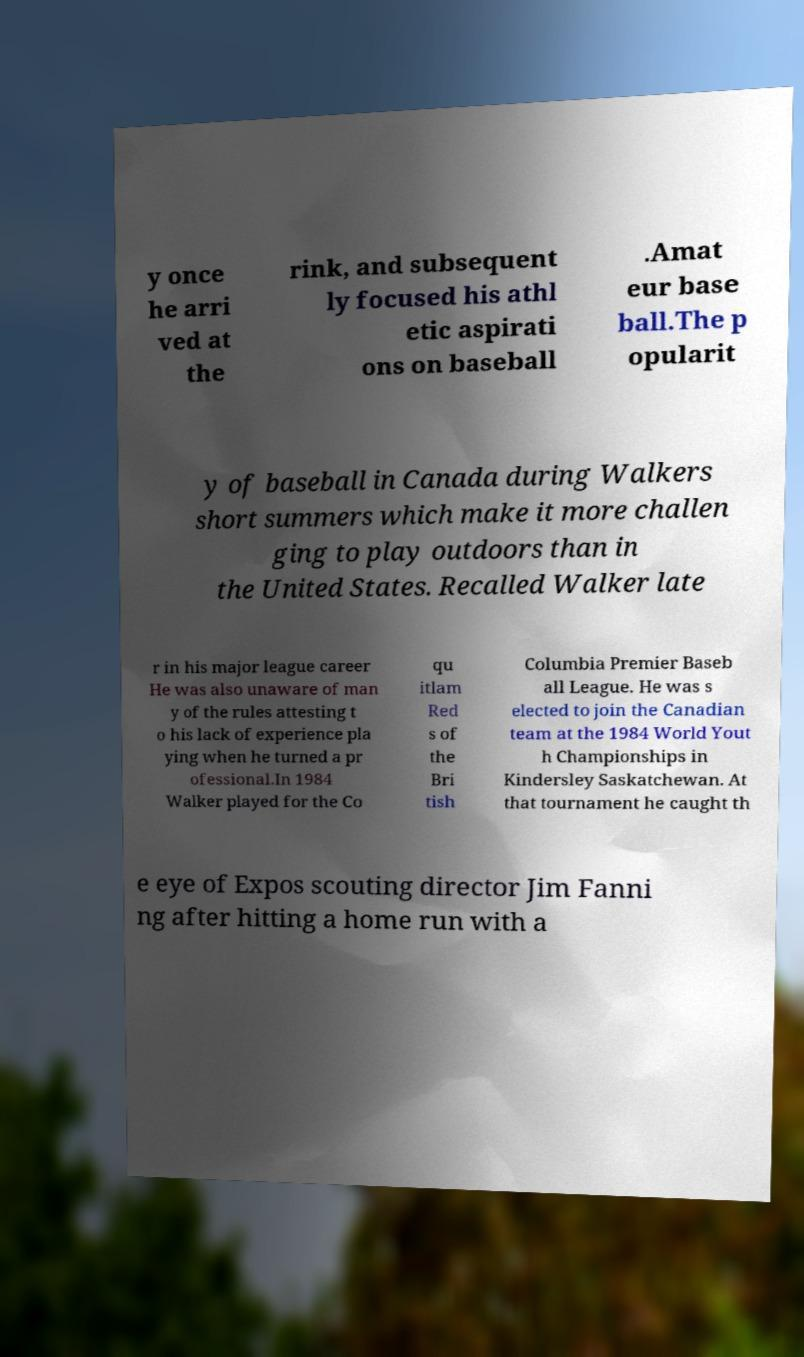Please read and relay the text visible in this image. What does it say? y once he arri ved at the rink, and subsequent ly focused his athl etic aspirati ons on baseball .Amat eur base ball.The p opularit y of baseball in Canada during Walkers short summers which make it more challen ging to play outdoors than in the United States. Recalled Walker late r in his major league career He was also unaware of man y of the rules attesting t o his lack of experience pla ying when he turned a pr ofessional.In 1984 Walker played for the Co qu itlam Red s of the Bri tish Columbia Premier Baseb all League. He was s elected to join the Canadian team at the 1984 World Yout h Championships in Kindersley Saskatchewan. At that tournament he caught th e eye of Expos scouting director Jim Fanni ng after hitting a home run with a 